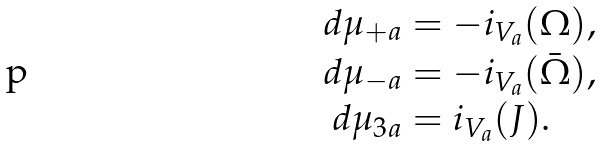Convert formula to latex. <formula><loc_0><loc_0><loc_500><loc_500>d \mu _ { + a } & = - i _ { V _ { a } } ( \Omega ) , \\ d \mu _ { - a } & = - i _ { V _ { a } } ( \bar { \Omega } ) , \\ d \mu _ { 3 a } & = i _ { V _ { a } } ( J ) .</formula> 